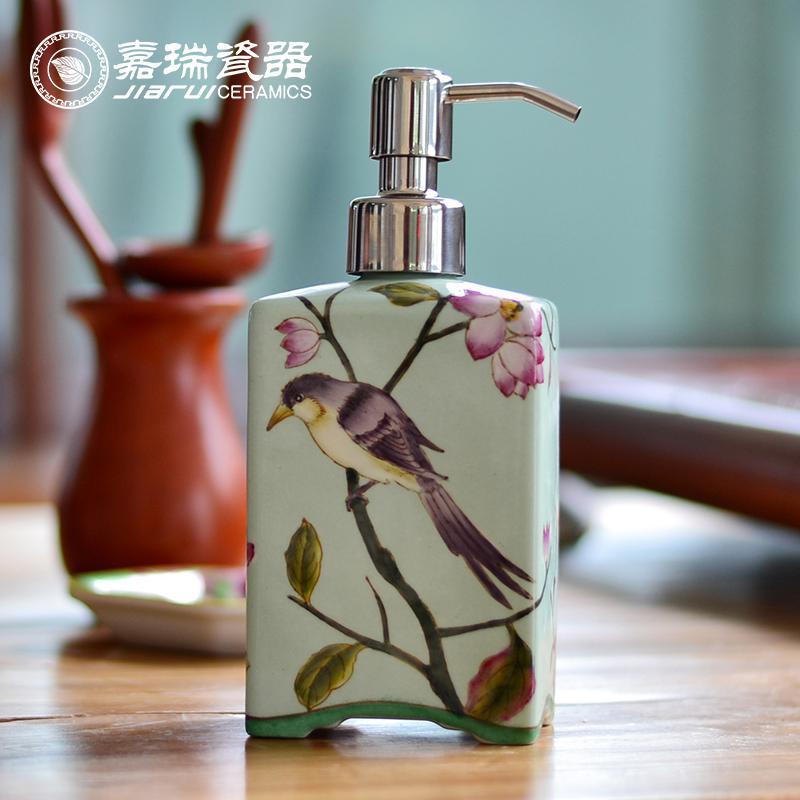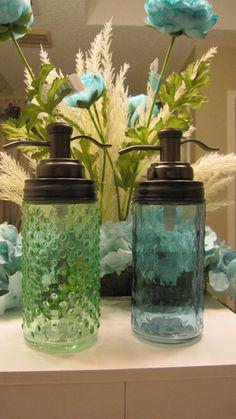The first image is the image on the left, the second image is the image on the right. Examine the images to the left and right. Is the description "The image on the right has pink flowers inside of a vase." accurate? Answer yes or no. No. 